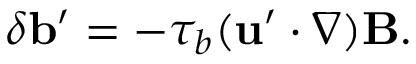Convert formula to latex. <formula><loc_0><loc_0><loc_500><loc_500>\delta { b } ^ { \prime } = - \tau _ { b } ( { u } ^ { \prime } \cdot \nabla ) { B } .</formula> 